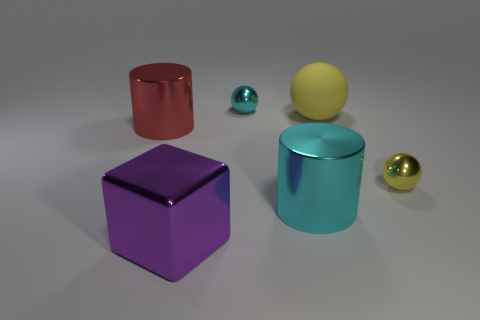Subtract all cyan balls. Subtract all blue cylinders. How many balls are left? 2 Add 1 large cylinders. How many objects exist? 7 Subtract all cylinders. How many objects are left? 4 Add 5 big shiny blocks. How many big shiny blocks are left? 6 Add 2 tiny yellow spheres. How many tiny yellow spheres exist? 3 Subtract 0 brown cylinders. How many objects are left? 6 Subtract all big metallic spheres. Subtract all purple blocks. How many objects are left? 5 